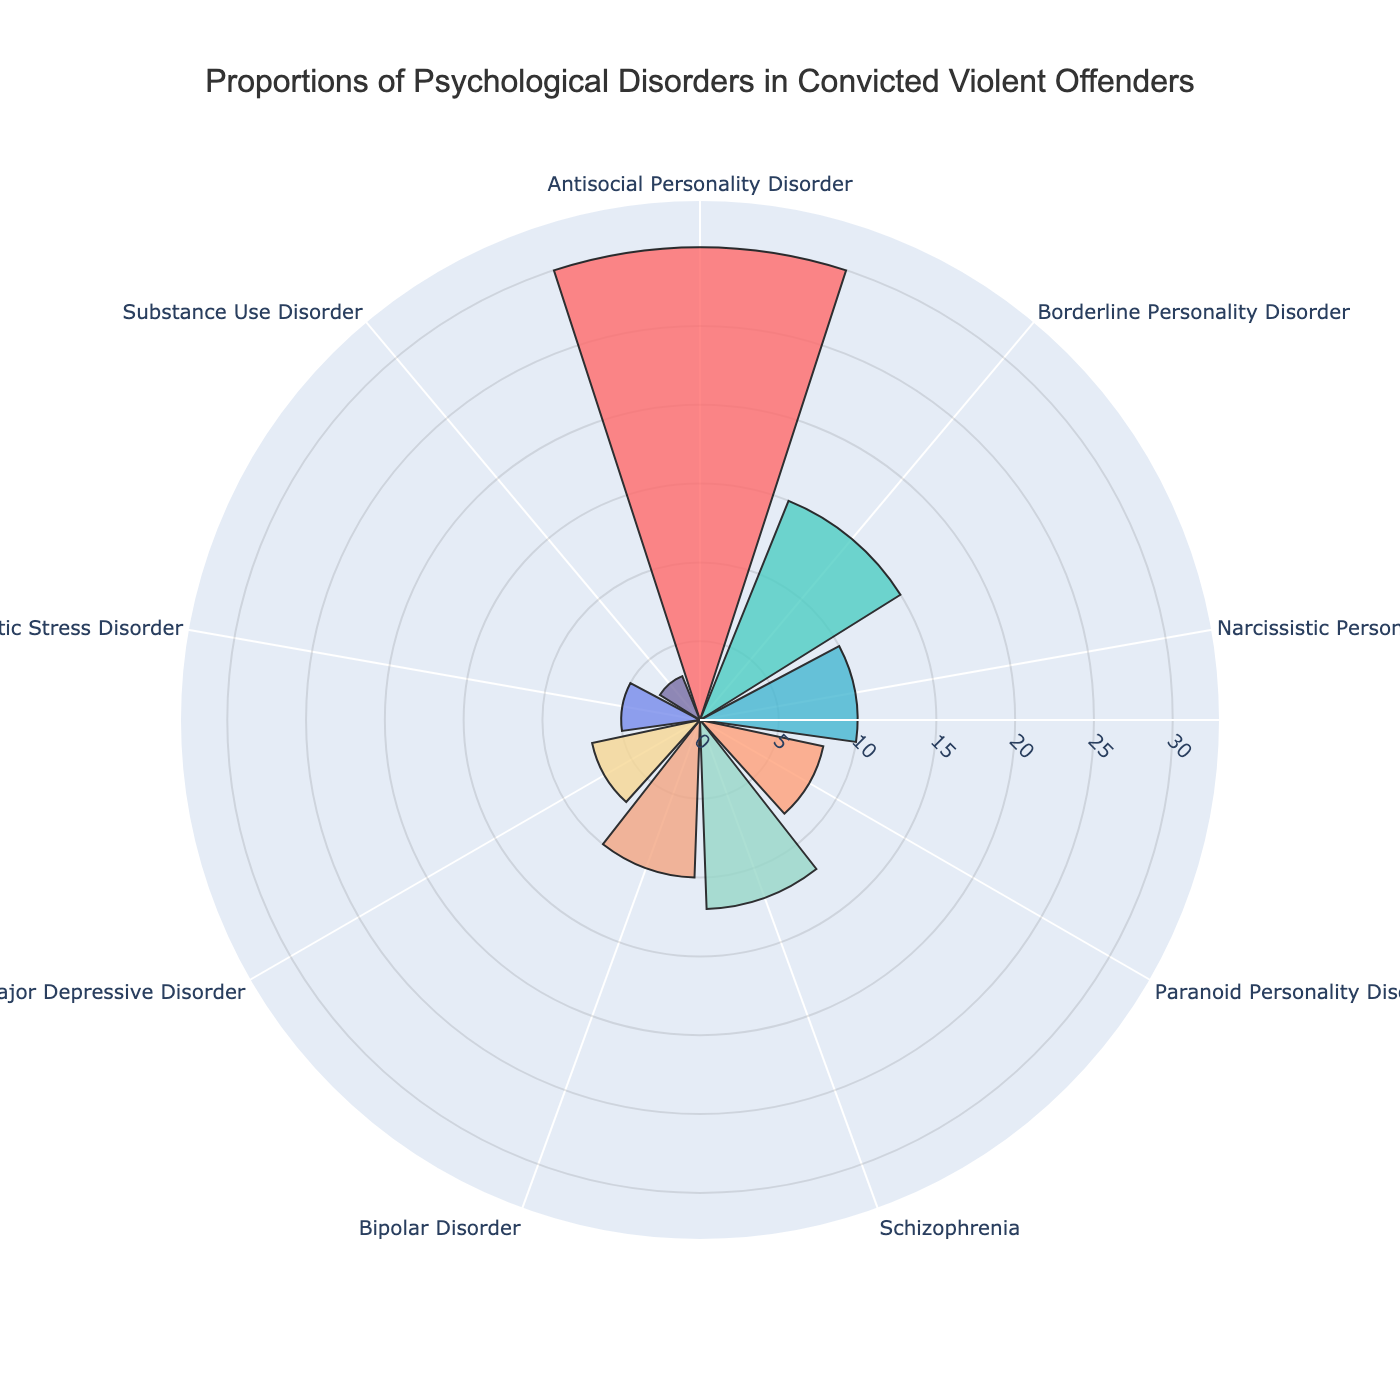what is the title of the figure? The title of the figure is typically displayed at the top and provides a succinct description of what the chart is about. Here, it's "Proportions of Psychological Disorders in Convicted Violent Offenders."
Answer: Proportions of Psychological Disorders in Convicted Violent Offenders Which category has the highest proportion? To determine the highest proportion, visually compare the lengths of the bars. The Antisocial Personality Disorder bar extends the furthest out.
Answer: Antisocial Personality Disorder What is the smallest proportion reported? The smallest proportion can be identified by looking for the shortest bar in the polar area chart. The shortest bar corresponds to Substance Use Disorder.
Answer: 3 How does Borderline Personality Disorder proportion compare to Schizophrenia? The bar for Borderline Personality Disorder is longer than the one for Schizophrenia. Therefore, the proportion of Borderline Personality Disorder is higher.
Answer: Higher What is the combined proportion of Bipolar Disorder and Major Depressive Disorder? Add the proportions of Bipolar Disorder (10) and Major Depressive Disorder (7). The combined proportion is 10 + 7.
Answer: 17 How many categories have a proportion higher than 10? Count the number of bars that extend beyond the 10-unit mark. These categories include Antisocial Personality Disorder, Borderline Personality Disorder, and Schizophrenia.
Answer: 3 Which disorder has a proportion of 12? Look at the bars labeled with proportions and identify which one corresponds to 12. That would be Schizophrenia.
Answer: Schizophrenia What is the difference in proportion between Antisocial Personality Disorder and Narcissistic Personality Disorder? Subtract the proportion of Narcissistic Personality Disorder (10) from Antisocial Personality Disorder (30). The difference is 30 - 10.
Answer: 20 What is the average proportion of all listed disorders? Sum all listed proportions and divide by the number of categories. (30 + 15 + 10 + 8 + 12 + 10 + 7 + 5 + 3) / 9 = 100 / 9
Answer: 11.11 Which disorder shows a proportion closest to the median value of all categories? List the proportions: 30, 15, 10, 8, 12, 10, 7, 5, 3. Sort these values: 3, 5, 7, 8, 10, 10, 12, 15, 30. The median is the middle value, which is 10. The disorders with a proportion of 10 are Narcissistic Personality Disorder and Bipolar Disorder.
Answer: Narcissistic Personality Disorder, Bipolar Disorder 